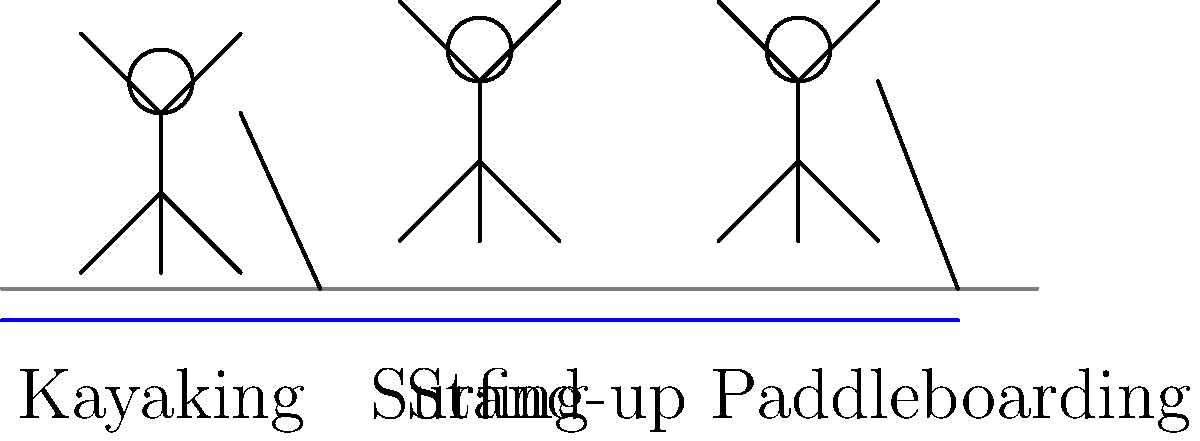Based on the stick figure diagrams, which water sport requires the most upright body positioning for optimal performance? To determine which water sport requires the most upright body positioning, let's analyze each sport's stick figure representation:

1. Surfing:
   - The stick figure is shown in a slightly crouched position.
   - The body is angled forward for balance and maneuverability.
   - The legs are bent to maintain stability on the surfboard.

2. Stand-up Paddleboarding (SUP):
   - The stick figure is standing fully upright on the paddleboard.
   - The body is straight and vertical for maximum stability and paddle reach.
   - The arms are extended upwards, holding the paddle.

3. Kayaking:
   - The stick figure is seated in the kayak.
   - The upper body is slightly leaned forward for efficient paddling.
   - The legs are bent and positioned inside the kayak.

Comparing the three sports:
- Surfing requires a more dynamic, crouched position for balance and control.
- Kayaking involves a seated position with a slight forward lean.
- Stand-up Paddleboarding demands the most upright stance to maintain balance on the board and effectively use the paddle.

Therefore, based on the stick figure diagrams, Stand-up Paddleboarding requires the most upright body positioning for optimal performance.
Answer: Stand-up Paddleboarding 